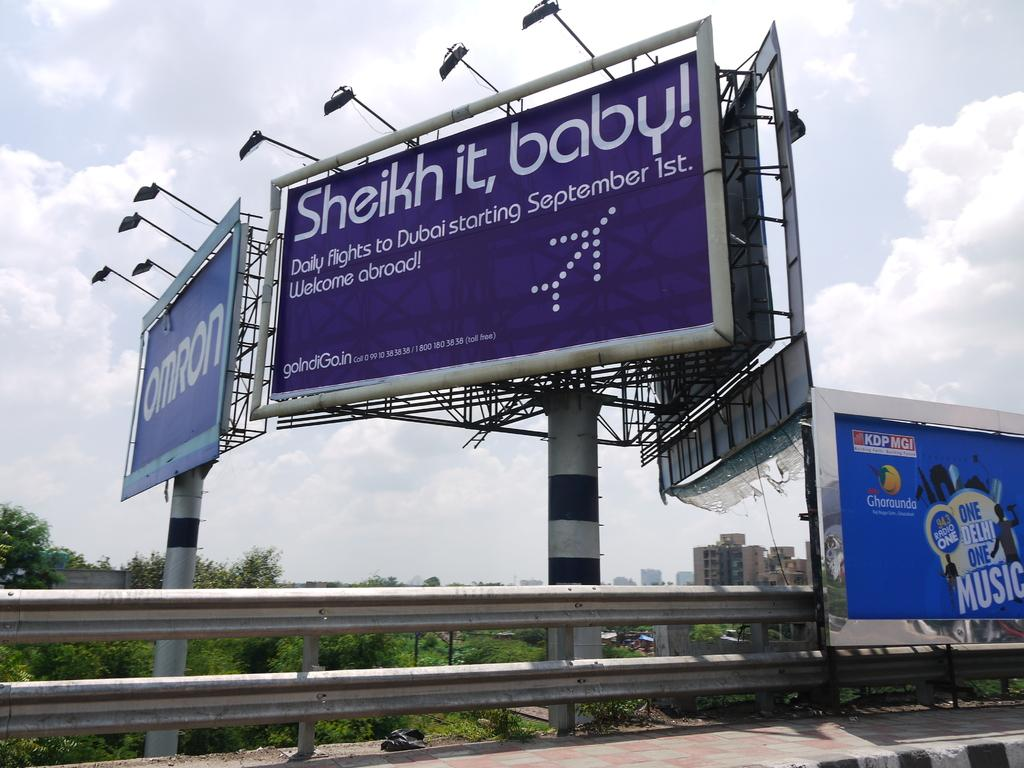<image>
Relay a brief, clear account of the picture shown. A purple billboard advertising for Dubai flights tells viewers to "Sheik it, baby!" 